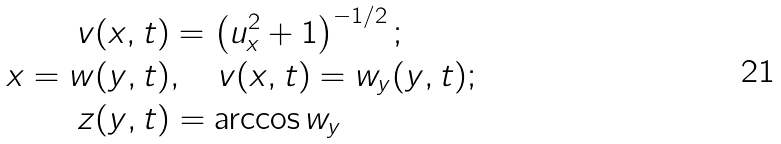<formula> <loc_0><loc_0><loc_500><loc_500>v & ( x , t ) = \left ( u _ { x } ^ { 2 } + 1 \right ) ^ { - 1 / 2 } ; \\ x = w & ( y , t ) , \quad v ( x , t ) = w _ { y } ( y , t ) ; \\ z & ( y , t ) = \arccos w _ { y }</formula> 